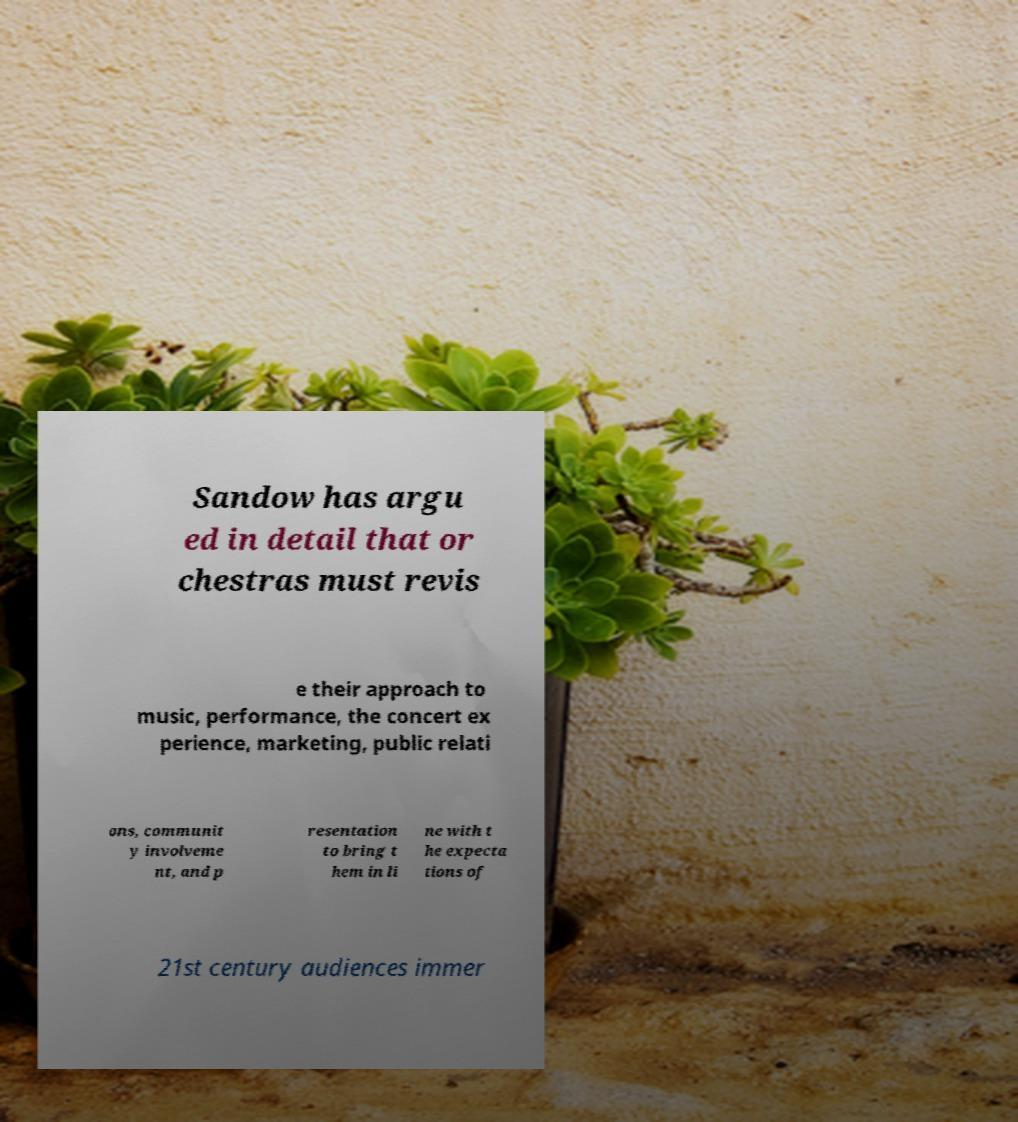I need the written content from this picture converted into text. Can you do that? Sandow has argu ed in detail that or chestras must revis e their approach to music, performance, the concert ex perience, marketing, public relati ons, communit y involveme nt, and p resentation to bring t hem in li ne with t he expecta tions of 21st century audiences immer 